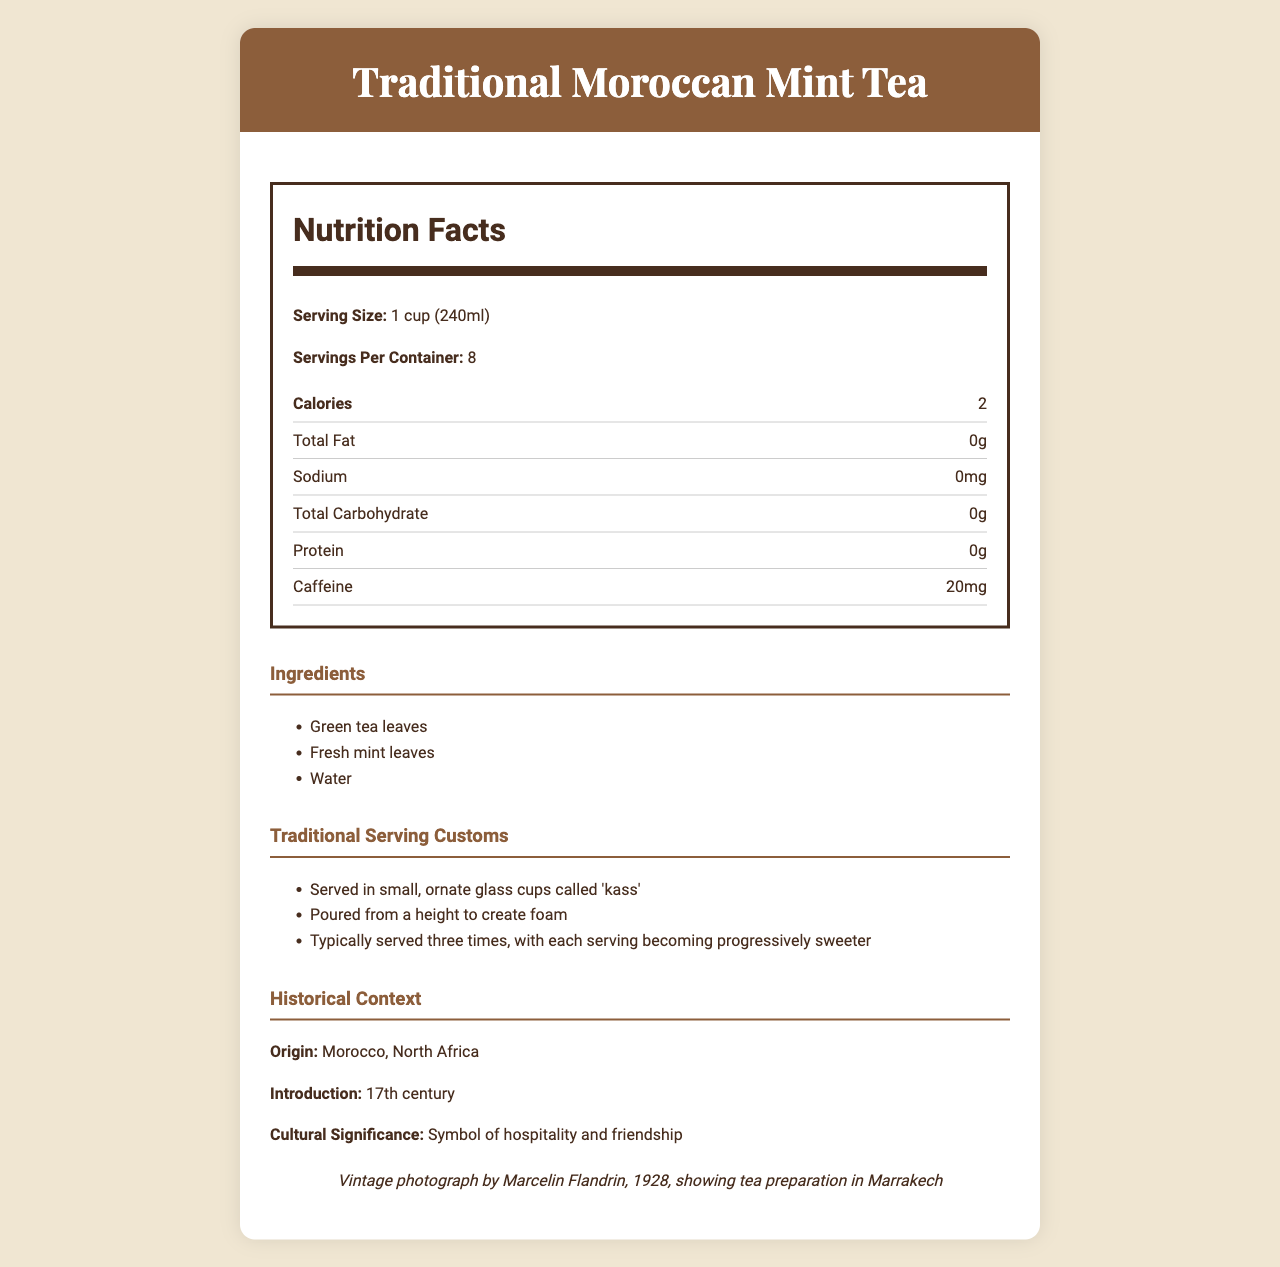what is the serving size? The serving size is explicitly mentioned as "1 cup (240ml)" in the Nutrition Facts section.
Answer: 1 cup (240ml) how many calories are in a serving of Traditional Moroccan Mint Tea? The number of calories per serving is given as "2" in the Nutrition Facts section.
Answer: 2 list the main ingredients of Traditional Moroccan Mint Tea. The ingredients section lists "Green tea leaves, Fresh mint leaves, Water."
Answer: Green tea leaves, Fresh mint leaves, Water what are the traditional serving customs of Moroccan mint tea? The document includes a section titled Traditional Serving Customs that provides these details.
Answer: Served in small, ornate glass cups called 'kass'; Poured from a height to create foam; Typically served three times, with each serving becoming progressively sweeter what are some of the health benefits of Moroccan mint tea? These health benefits are listed in the document under health benefits.
Answer: Rich in antioxidants, May aid digestion, Naturally caffeine-free when made with only mint leaves where did Moroccan mint tea originate? The origin of Moroccan mint tea is mentioned in the Historical Context section as "Morocco, North Africa."
Answer: Morocco, North Africa which of the following is a traditional element of serving Moroccan mint tea? A. Served with honey B. Poured from a height to create foam C. Served with lemon slices The traditional service includes pouring from a height to create foam, as listed in Traditional Serving Customs.
Answer: B how much caffeine is in a serving? A. 10mg B. 20mg C. 30mg The caffeine content per serving is noted as "20mg" in the Nutrition Facts section.
Answer: B is there any protein in Moroccan mint tea? The Nutrition Facts indicate there is "0g" of protein in each serving.
Answer: No does the traditional preparation method include adding sugar? While the preparation method mentions that sugar can be added, it is optional and not included in the nutrition facts.
Answer: It can be optionally added to taste can you summarize the document? The document covers various aspects of Traditional Moroccan Mint Tea, from its nutritional content to traditional practices and health benefits. Details on ingredients, preparation methods, and serving customs highlight the tea's cultural significance and versatility.
Answer: The document provides nutritional information, historical context, traditional serving customs, and health benefits of Traditional Moroccan Mint Tea. It emphasizes the tea's low calorie content, typical ingredients, and cultural significance, along with different regional variations and consumption tips. does the document mention when Moroccan mint tea was introduced? The Historical Context section states that the tea was introduced in the "17th century".
Answer: Yes, in the 17th century how is Moroccan mint tea served in Tunisia? The regional variations section mentions that in Tunisia, Moroccan mint tea is often served with pine nuts.
Answer: Often served with pine nuts what is the caloric content per container of Moroccan mint tea? Each serving is 2 calories, and with 8 servings per container, the total caloric content is 16 calories.
Answer: 16 calories what sweet treat is commonly served with Moroccan mint tea? The consumption tips mention it can be served with traditional Moroccan sweets like 'kaab el ghzal'.
Answer: Moroccan sweets like 'kaab el ghzal' is Moroccan mint tea high in sodium? The Nutrition Facts state that the sodium content is "0mg".
Answer: No how can the caffeine content be described when Moroccan mint tea is made with only mint leaves? The health benefits section notes that it is naturally caffeine-free when made with only mint leaves.
Answer: Naturally caffeine-free which regional variation includes sage? A. Tunisia B. Algeria C. Egypt The document mentions that Algerian variation sometimes includes sage or wormwood.
Answer: B how many servings are there per container? The Nutrition Facts specify that there are "8 servings per container."
Answer: 8 what historical photograph is referenced in the document? This is mentioned in the photographic reference section.
Answer: Vintage photograph by Marcelin Flandrin, 1928, showing tea preparation in Marrakech who first introduced Moroccan mint tea? The document does not specify who first introduced Moroccan mint tea, only that it was introduced in the 17th century.
Answer: Not enough information 